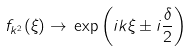Convert formula to latex. <formula><loc_0><loc_0><loc_500><loc_500>f _ { k ^ { 2 } } ( \xi ) \rightarrow \, \exp \left ( i k \xi \pm i \frac { \delta } { 2 } \right )</formula> 